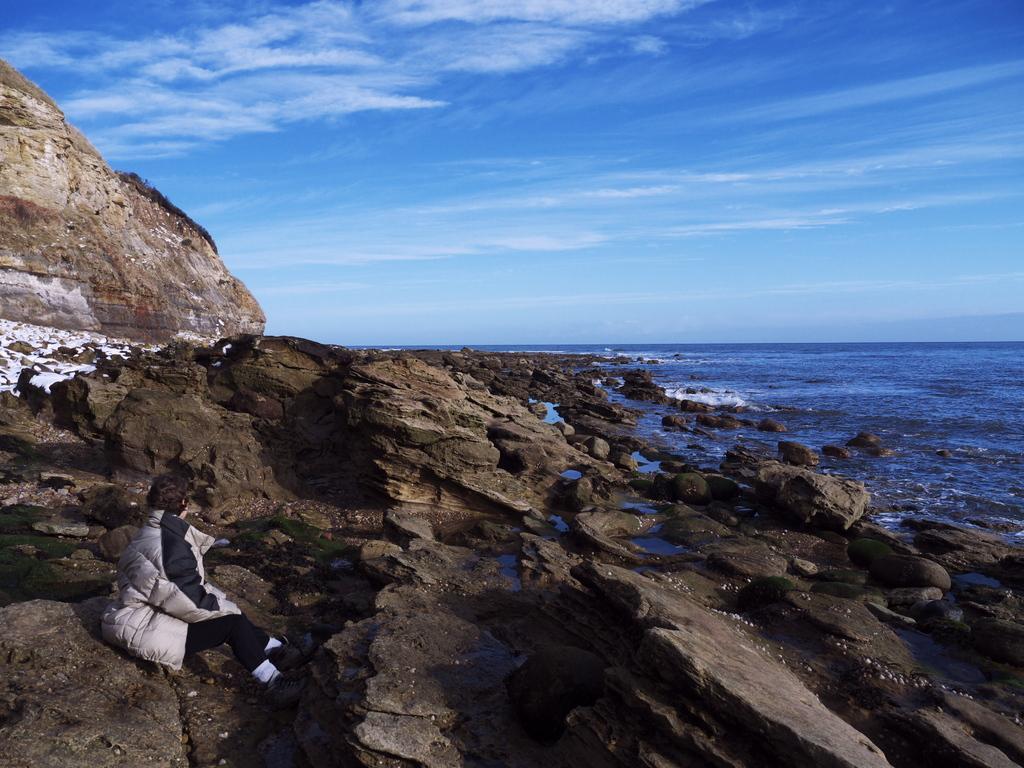Please provide a concise description of this image. In the bottom left there is a woman who is sitting on the stone. On the left there is a stone mountain. At the top we can see sky and clouds. On the left right we can see the ocean. 